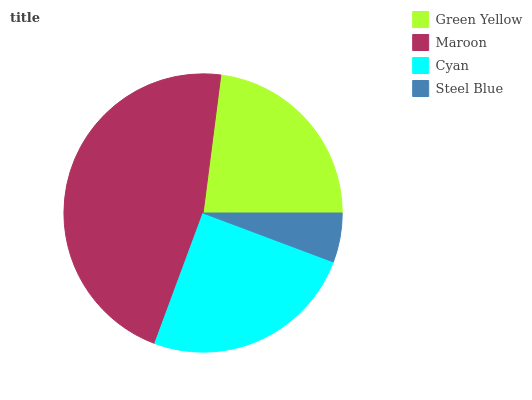Is Steel Blue the minimum?
Answer yes or no. Yes. Is Maroon the maximum?
Answer yes or no. Yes. Is Cyan the minimum?
Answer yes or no. No. Is Cyan the maximum?
Answer yes or no. No. Is Maroon greater than Cyan?
Answer yes or no. Yes. Is Cyan less than Maroon?
Answer yes or no. Yes. Is Cyan greater than Maroon?
Answer yes or no. No. Is Maroon less than Cyan?
Answer yes or no. No. Is Cyan the high median?
Answer yes or no. Yes. Is Green Yellow the low median?
Answer yes or no. Yes. Is Steel Blue the high median?
Answer yes or no. No. Is Maroon the low median?
Answer yes or no. No. 